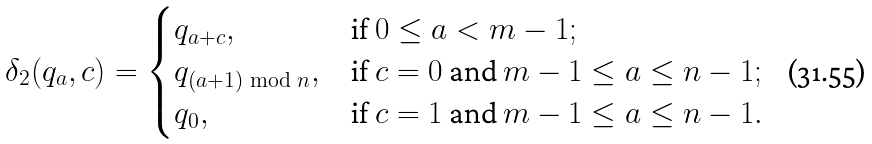<formula> <loc_0><loc_0><loc_500><loc_500>\delta _ { 2 } ( q _ { a } , c ) = \begin{cases} q _ { a + c } , & \text {if } 0 \leq a < m - 1 ; \\ q _ { ( a + 1 ) \bmod n } , & \text {if } c = 0 \text { and } m - 1 \leq a \leq n - 1 ; \\ q _ { 0 } , & \text {if } c = 1 \text { and } m - 1 \leq a \leq n - 1 . \end{cases}</formula> 